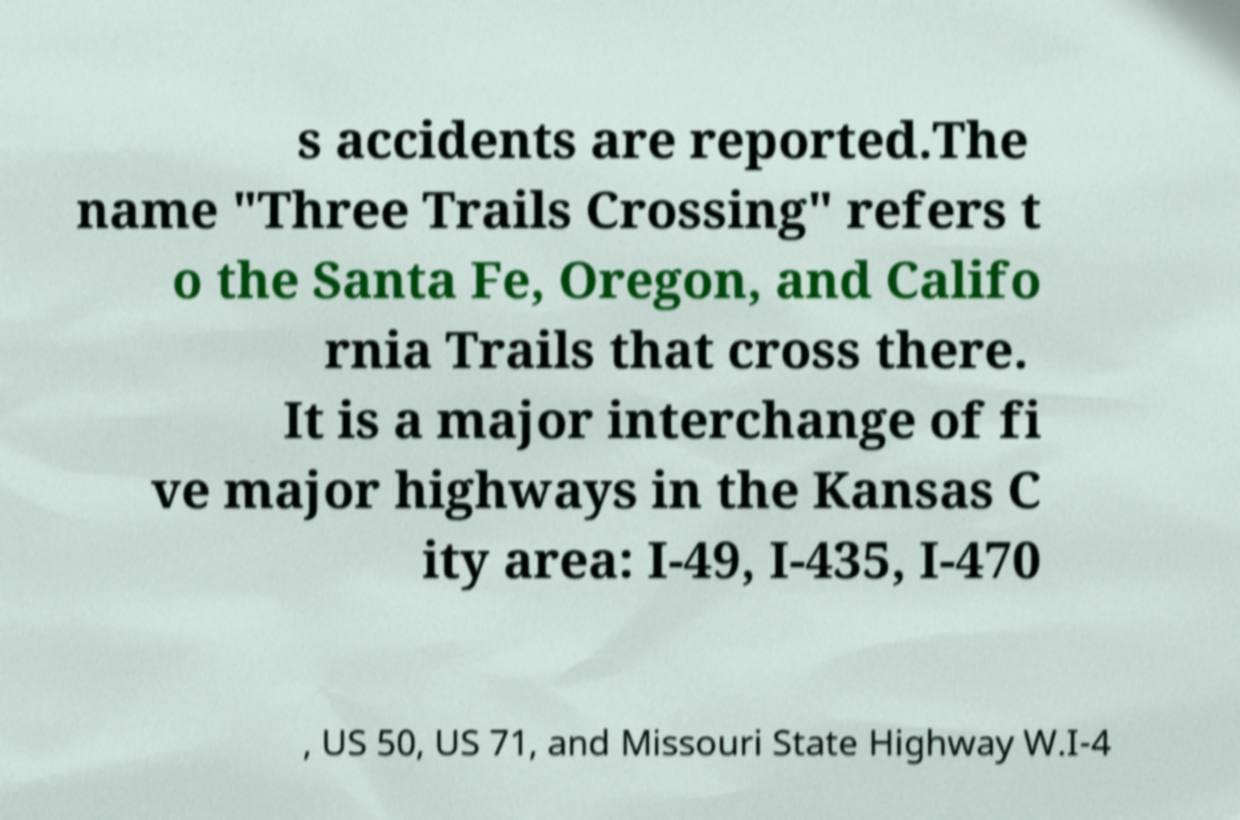Can you accurately transcribe the text from the provided image for me? s accidents are reported.The name "Three Trails Crossing" refers t o the Santa Fe, Oregon, and Califo rnia Trails that cross there. It is a major interchange of fi ve major highways in the Kansas C ity area: I-49, I-435, I-470 , US 50, US 71, and Missouri State Highway W.I-4 